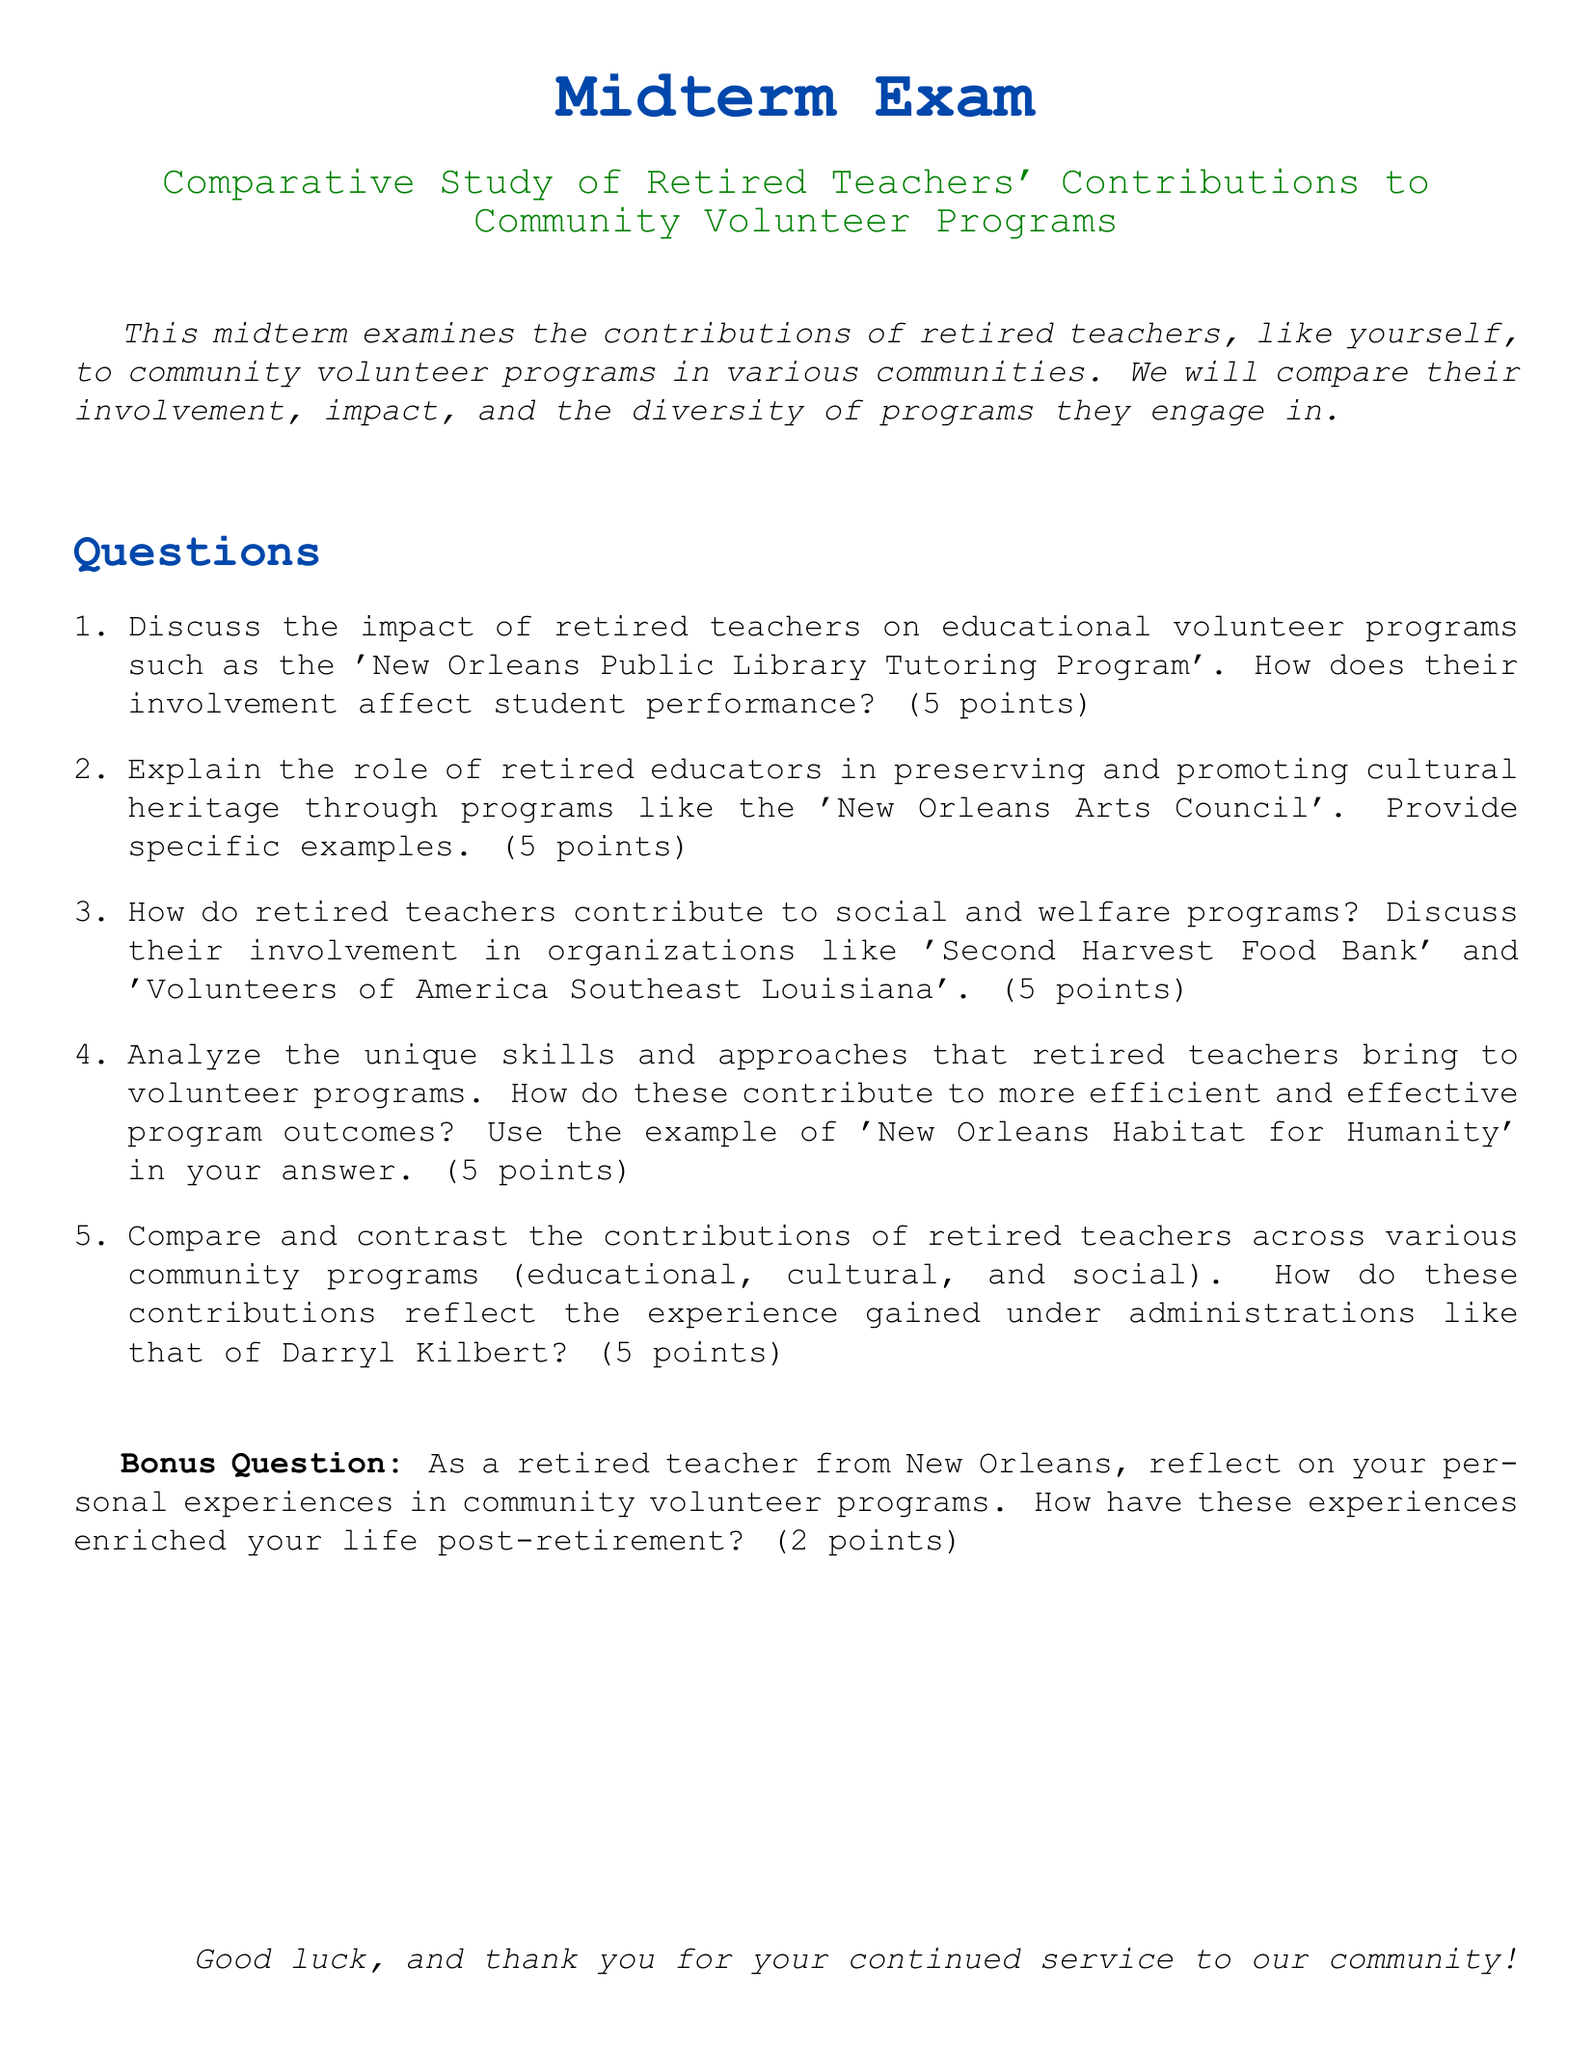What is the title of the midterm exam? The title of the midterm exam is highlighted at the top of the document.
Answer: Midterm Exam What color is used for section titles? The document states the color used for section titles, which is specified in the code.
Answer: myblue How many points is each question worth? The document specifies the point value allocated to each question in the exam.
Answer: 5 points What is the bonus question worth? The document states the point value for the bonus question specifically.
Answer: 2 points Which program is mentioned as part of the educational volunteer programs? The document lists specific volunteer programs as examples under educational contributions.
Answer: New Orleans Public Library Tutoring Program Name one cultural program that retired educators contribute to. The document includes specific examples of cultural programs where retired teachers engage.
Answer: New Orleans Arts Council What impact do retired teachers have on student performance? The document indicates the role of retired teachers in educational programs and their effect on students.
Answer: Positive impact Which organization is mentioned in relation to social and welfare programs? The document gives examples of organizations that retired educators contribute to within social programs.
Answer: Second Harvest Food Bank What is emphasized about retired teachers' experiences under administrations? The document discusses how the experiences of retired teachers are reflected in their contributions.
Answer: Unique insights 